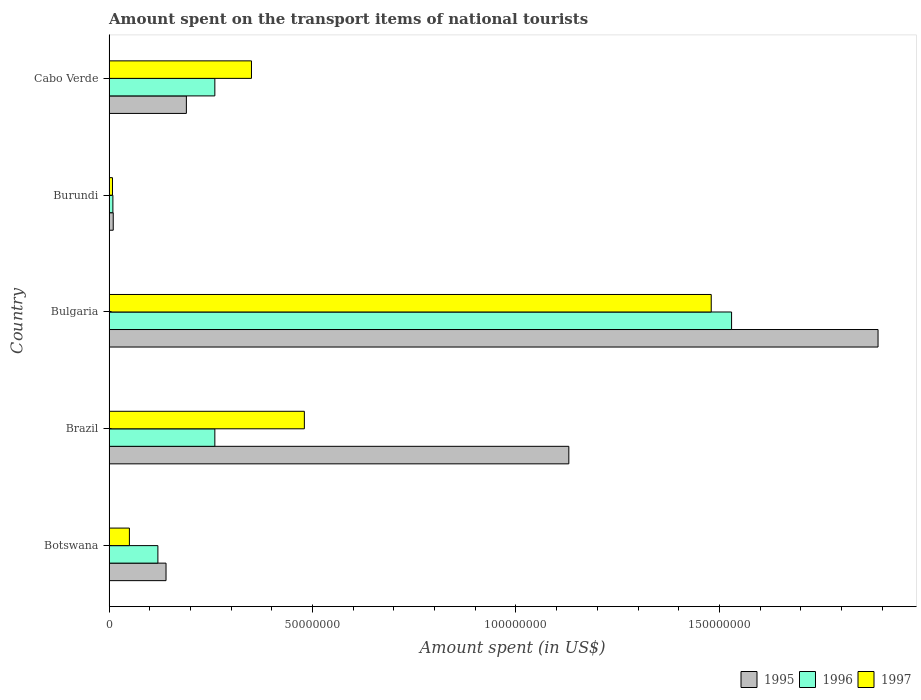How many bars are there on the 3rd tick from the top?
Provide a short and direct response. 3. What is the label of the 2nd group of bars from the top?
Provide a succinct answer. Burundi. What is the amount spent on the transport items of national tourists in 1997 in Botswana?
Provide a short and direct response. 5.00e+06. Across all countries, what is the maximum amount spent on the transport items of national tourists in 1995?
Offer a very short reply. 1.89e+08. Across all countries, what is the minimum amount spent on the transport items of national tourists in 1996?
Keep it short and to the point. 9.41e+05. In which country was the amount spent on the transport items of national tourists in 1996 minimum?
Keep it short and to the point. Burundi. What is the total amount spent on the transport items of national tourists in 1995 in the graph?
Keep it short and to the point. 3.36e+08. What is the difference between the amount spent on the transport items of national tourists in 1996 in Bulgaria and that in Burundi?
Give a very brief answer. 1.52e+08. What is the difference between the amount spent on the transport items of national tourists in 1996 in Brazil and the amount spent on the transport items of national tourists in 1997 in Cabo Verde?
Offer a terse response. -9.00e+06. What is the average amount spent on the transport items of national tourists in 1997 per country?
Make the answer very short. 4.74e+07. What is the difference between the amount spent on the transport items of national tourists in 1997 and amount spent on the transport items of national tourists in 1996 in Brazil?
Give a very brief answer. 2.20e+07. In how many countries, is the amount spent on the transport items of national tourists in 1996 greater than 110000000 US$?
Your answer should be compact. 1. What is the ratio of the amount spent on the transport items of national tourists in 1996 in Bulgaria to that in Burundi?
Ensure brevity in your answer.  162.53. What is the difference between the highest and the second highest amount spent on the transport items of national tourists in 1995?
Provide a short and direct response. 7.60e+07. What is the difference between the highest and the lowest amount spent on the transport items of national tourists in 1996?
Give a very brief answer. 1.52e+08. What does the 3rd bar from the bottom in Brazil represents?
Your answer should be very brief. 1997. What is the difference between two consecutive major ticks on the X-axis?
Your response must be concise. 5.00e+07. Does the graph contain any zero values?
Keep it short and to the point. No. Does the graph contain grids?
Keep it short and to the point. No. How are the legend labels stacked?
Provide a short and direct response. Horizontal. What is the title of the graph?
Offer a very short reply. Amount spent on the transport items of national tourists. Does "1980" appear as one of the legend labels in the graph?
Give a very brief answer. No. What is the label or title of the X-axis?
Ensure brevity in your answer.  Amount spent (in US$). What is the Amount spent (in US$) in 1995 in Botswana?
Your answer should be very brief. 1.40e+07. What is the Amount spent (in US$) of 1996 in Botswana?
Your answer should be very brief. 1.20e+07. What is the Amount spent (in US$) in 1997 in Botswana?
Make the answer very short. 5.00e+06. What is the Amount spent (in US$) in 1995 in Brazil?
Make the answer very short. 1.13e+08. What is the Amount spent (in US$) of 1996 in Brazil?
Give a very brief answer. 2.60e+07. What is the Amount spent (in US$) of 1997 in Brazil?
Make the answer very short. 4.80e+07. What is the Amount spent (in US$) in 1995 in Bulgaria?
Keep it short and to the point. 1.89e+08. What is the Amount spent (in US$) in 1996 in Bulgaria?
Your answer should be compact. 1.53e+08. What is the Amount spent (in US$) of 1997 in Bulgaria?
Offer a terse response. 1.48e+08. What is the Amount spent (in US$) of 1995 in Burundi?
Your response must be concise. 1.02e+06. What is the Amount spent (in US$) of 1996 in Burundi?
Your answer should be very brief. 9.41e+05. What is the Amount spent (in US$) in 1997 in Burundi?
Ensure brevity in your answer.  8.40e+05. What is the Amount spent (in US$) of 1995 in Cabo Verde?
Offer a terse response. 1.90e+07. What is the Amount spent (in US$) of 1996 in Cabo Verde?
Make the answer very short. 2.60e+07. What is the Amount spent (in US$) in 1997 in Cabo Verde?
Offer a very short reply. 3.50e+07. Across all countries, what is the maximum Amount spent (in US$) in 1995?
Your answer should be compact. 1.89e+08. Across all countries, what is the maximum Amount spent (in US$) of 1996?
Ensure brevity in your answer.  1.53e+08. Across all countries, what is the maximum Amount spent (in US$) of 1997?
Ensure brevity in your answer.  1.48e+08. Across all countries, what is the minimum Amount spent (in US$) in 1995?
Offer a terse response. 1.02e+06. Across all countries, what is the minimum Amount spent (in US$) in 1996?
Your response must be concise. 9.41e+05. Across all countries, what is the minimum Amount spent (in US$) of 1997?
Give a very brief answer. 8.40e+05. What is the total Amount spent (in US$) in 1995 in the graph?
Ensure brevity in your answer.  3.36e+08. What is the total Amount spent (in US$) in 1996 in the graph?
Make the answer very short. 2.18e+08. What is the total Amount spent (in US$) in 1997 in the graph?
Your response must be concise. 2.37e+08. What is the difference between the Amount spent (in US$) in 1995 in Botswana and that in Brazil?
Provide a succinct answer. -9.90e+07. What is the difference between the Amount spent (in US$) in 1996 in Botswana and that in Brazil?
Your answer should be compact. -1.40e+07. What is the difference between the Amount spent (in US$) in 1997 in Botswana and that in Brazil?
Offer a very short reply. -4.30e+07. What is the difference between the Amount spent (in US$) in 1995 in Botswana and that in Bulgaria?
Provide a short and direct response. -1.75e+08. What is the difference between the Amount spent (in US$) of 1996 in Botswana and that in Bulgaria?
Offer a terse response. -1.41e+08. What is the difference between the Amount spent (in US$) in 1997 in Botswana and that in Bulgaria?
Ensure brevity in your answer.  -1.43e+08. What is the difference between the Amount spent (in US$) of 1995 in Botswana and that in Burundi?
Provide a succinct answer. 1.30e+07. What is the difference between the Amount spent (in US$) in 1996 in Botswana and that in Burundi?
Give a very brief answer. 1.11e+07. What is the difference between the Amount spent (in US$) of 1997 in Botswana and that in Burundi?
Offer a terse response. 4.16e+06. What is the difference between the Amount spent (in US$) of 1995 in Botswana and that in Cabo Verde?
Offer a very short reply. -5.00e+06. What is the difference between the Amount spent (in US$) of 1996 in Botswana and that in Cabo Verde?
Your response must be concise. -1.40e+07. What is the difference between the Amount spent (in US$) of 1997 in Botswana and that in Cabo Verde?
Ensure brevity in your answer.  -3.00e+07. What is the difference between the Amount spent (in US$) in 1995 in Brazil and that in Bulgaria?
Ensure brevity in your answer.  -7.60e+07. What is the difference between the Amount spent (in US$) in 1996 in Brazil and that in Bulgaria?
Offer a very short reply. -1.27e+08. What is the difference between the Amount spent (in US$) of 1997 in Brazil and that in Bulgaria?
Your response must be concise. -1.00e+08. What is the difference between the Amount spent (in US$) in 1995 in Brazil and that in Burundi?
Provide a succinct answer. 1.12e+08. What is the difference between the Amount spent (in US$) of 1996 in Brazil and that in Burundi?
Ensure brevity in your answer.  2.51e+07. What is the difference between the Amount spent (in US$) of 1997 in Brazil and that in Burundi?
Give a very brief answer. 4.72e+07. What is the difference between the Amount spent (in US$) in 1995 in Brazil and that in Cabo Verde?
Your answer should be compact. 9.40e+07. What is the difference between the Amount spent (in US$) in 1996 in Brazil and that in Cabo Verde?
Keep it short and to the point. 0. What is the difference between the Amount spent (in US$) in 1997 in Brazil and that in Cabo Verde?
Your response must be concise. 1.30e+07. What is the difference between the Amount spent (in US$) in 1995 in Bulgaria and that in Burundi?
Make the answer very short. 1.88e+08. What is the difference between the Amount spent (in US$) of 1996 in Bulgaria and that in Burundi?
Ensure brevity in your answer.  1.52e+08. What is the difference between the Amount spent (in US$) in 1997 in Bulgaria and that in Burundi?
Give a very brief answer. 1.47e+08. What is the difference between the Amount spent (in US$) in 1995 in Bulgaria and that in Cabo Verde?
Your answer should be compact. 1.70e+08. What is the difference between the Amount spent (in US$) in 1996 in Bulgaria and that in Cabo Verde?
Provide a short and direct response. 1.27e+08. What is the difference between the Amount spent (in US$) in 1997 in Bulgaria and that in Cabo Verde?
Keep it short and to the point. 1.13e+08. What is the difference between the Amount spent (in US$) of 1995 in Burundi and that in Cabo Verde?
Offer a very short reply. -1.80e+07. What is the difference between the Amount spent (in US$) in 1996 in Burundi and that in Cabo Verde?
Your response must be concise. -2.51e+07. What is the difference between the Amount spent (in US$) of 1997 in Burundi and that in Cabo Verde?
Your answer should be compact. -3.42e+07. What is the difference between the Amount spent (in US$) in 1995 in Botswana and the Amount spent (in US$) in 1996 in Brazil?
Give a very brief answer. -1.20e+07. What is the difference between the Amount spent (in US$) of 1995 in Botswana and the Amount spent (in US$) of 1997 in Brazil?
Ensure brevity in your answer.  -3.40e+07. What is the difference between the Amount spent (in US$) in 1996 in Botswana and the Amount spent (in US$) in 1997 in Brazil?
Keep it short and to the point. -3.60e+07. What is the difference between the Amount spent (in US$) in 1995 in Botswana and the Amount spent (in US$) in 1996 in Bulgaria?
Your answer should be very brief. -1.39e+08. What is the difference between the Amount spent (in US$) of 1995 in Botswana and the Amount spent (in US$) of 1997 in Bulgaria?
Offer a terse response. -1.34e+08. What is the difference between the Amount spent (in US$) in 1996 in Botswana and the Amount spent (in US$) in 1997 in Bulgaria?
Your answer should be very brief. -1.36e+08. What is the difference between the Amount spent (in US$) in 1995 in Botswana and the Amount spent (in US$) in 1996 in Burundi?
Ensure brevity in your answer.  1.31e+07. What is the difference between the Amount spent (in US$) of 1995 in Botswana and the Amount spent (in US$) of 1997 in Burundi?
Make the answer very short. 1.32e+07. What is the difference between the Amount spent (in US$) in 1996 in Botswana and the Amount spent (in US$) in 1997 in Burundi?
Provide a succinct answer. 1.12e+07. What is the difference between the Amount spent (in US$) of 1995 in Botswana and the Amount spent (in US$) of 1996 in Cabo Verde?
Make the answer very short. -1.20e+07. What is the difference between the Amount spent (in US$) in 1995 in Botswana and the Amount spent (in US$) in 1997 in Cabo Verde?
Provide a short and direct response. -2.10e+07. What is the difference between the Amount spent (in US$) in 1996 in Botswana and the Amount spent (in US$) in 1997 in Cabo Verde?
Your answer should be very brief. -2.30e+07. What is the difference between the Amount spent (in US$) in 1995 in Brazil and the Amount spent (in US$) in 1996 in Bulgaria?
Your response must be concise. -4.00e+07. What is the difference between the Amount spent (in US$) in 1995 in Brazil and the Amount spent (in US$) in 1997 in Bulgaria?
Keep it short and to the point. -3.50e+07. What is the difference between the Amount spent (in US$) of 1996 in Brazil and the Amount spent (in US$) of 1997 in Bulgaria?
Make the answer very short. -1.22e+08. What is the difference between the Amount spent (in US$) in 1995 in Brazil and the Amount spent (in US$) in 1996 in Burundi?
Your answer should be very brief. 1.12e+08. What is the difference between the Amount spent (in US$) of 1995 in Brazil and the Amount spent (in US$) of 1997 in Burundi?
Your answer should be very brief. 1.12e+08. What is the difference between the Amount spent (in US$) of 1996 in Brazil and the Amount spent (in US$) of 1997 in Burundi?
Your response must be concise. 2.52e+07. What is the difference between the Amount spent (in US$) in 1995 in Brazil and the Amount spent (in US$) in 1996 in Cabo Verde?
Your response must be concise. 8.70e+07. What is the difference between the Amount spent (in US$) of 1995 in Brazil and the Amount spent (in US$) of 1997 in Cabo Verde?
Provide a short and direct response. 7.80e+07. What is the difference between the Amount spent (in US$) in 1996 in Brazil and the Amount spent (in US$) in 1997 in Cabo Verde?
Offer a very short reply. -9.00e+06. What is the difference between the Amount spent (in US$) of 1995 in Bulgaria and the Amount spent (in US$) of 1996 in Burundi?
Provide a succinct answer. 1.88e+08. What is the difference between the Amount spent (in US$) of 1995 in Bulgaria and the Amount spent (in US$) of 1997 in Burundi?
Provide a succinct answer. 1.88e+08. What is the difference between the Amount spent (in US$) of 1996 in Bulgaria and the Amount spent (in US$) of 1997 in Burundi?
Provide a succinct answer. 1.52e+08. What is the difference between the Amount spent (in US$) in 1995 in Bulgaria and the Amount spent (in US$) in 1996 in Cabo Verde?
Provide a short and direct response. 1.63e+08. What is the difference between the Amount spent (in US$) in 1995 in Bulgaria and the Amount spent (in US$) in 1997 in Cabo Verde?
Your answer should be compact. 1.54e+08. What is the difference between the Amount spent (in US$) in 1996 in Bulgaria and the Amount spent (in US$) in 1997 in Cabo Verde?
Offer a very short reply. 1.18e+08. What is the difference between the Amount spent (in US$) in 1995 in Burundi and the Amount spent (in US$) in 1996 in Cabo Verde?
Provide a short and direct response. -2.50e+07. What is the difference between the Amount spent (in US$) of 1995 in Burundi and the Amount spent (in US$) of 1997 in Cabo Verde?
Ensure brevity in your answer.  -3.40e+07. What is the difference between the Amount spent (in US$) of 1996 in Burundi and the Amount spent (in US$) of 1997 in Cabo Verde?
Offer a terse response. -3.41e+07. What is the average Amount spent (in US$) of 1995 per country?
Give a very brief answer. 6.72e+07. What is the average Amount spent (in US$) of 1996 per country?
Keep it short and to the point. 4.36e+07. What is the average Amount spent (in US$) in 1997 per country?
Make the answer very short. 4.74e+07. What is the difference between the Amount spent (in US$) of 1995 and Amount spent (in US$) of 1997 in Botswana?
Provide a short and direct response. 9.00e+06. What is the difference between the Amount spent (in US$) in 1995 and Amount spent (in US$) in 1996 in Brazil?
Ensure brevity in your answer.  8.70e+07. What is the difference between the Amount spent (in US$) in 1995 and Amount spent (in US$) in 1997 in Brazil?
Provide a succinct answer. 6.50e+07. What is the difference between the Amount spent (in US$) of 1996 and Amount spent (in US$) of 1997 in Brazil?
Make the answer very short. -2.20e+07. What is the difference between the Amount spent (in US$) of 1995 and Amount spent (in US$) of 1996 in Bulgaria?
Offer a very short reply. 3.60e+07. What is the difference between the Amount spent (in US$) in 1995 and Amount spent (in US$) in 1997 in Bulgaria?
Give a very brief answer. 4.10e+07. What is the difference between the Amount spent (in US$) in 1995 and Amount spent (in US$) in 1996 in Burundi?
Your response must be concise. 8.36e+04. What is the difference between the Amount spent (in US$) in 1995 and Amount spent (in US$) in 1997 in Burundi?
Your answer should be very brief. 1.85e+05. What is the difference between the Amount spent (in US$) of 1996 and Amount spent (in US$) of 1997 in Burundi?
Provide a short and direct response. 1.01e+05. What is the difference between the Amount spent (in US$) in 1995 and Amount spent (in US$) in 1996 in Cabo Verde?
Give a very brief answer. -7.00e+06. What is the difference between the Amount spent (in US$) of 1995 and Amount spent (in US$) of 1997 in Cabo Verde?
Offer a very short reply. -1.60e+07. What is the difference between the Amount spent (in US$) in 1996 and Amount spent (in US$) in 1997 in Cabo Verde?
Offer a terse response. -9.00e+06. What is the ratio of the Amount spent (in US$) of 1995 in Botswana to that in Brazil?
Your answer should be very brief. 0.12. What is the ratio of the Amount spent (in US$) of 1996 in Botswana to that in Brazil?
Keep it short and to the point. 0.46. What is the ratio of the Amount spent (in US$) of 1997 in Botswana to that in Brazil?
Ensure brevity in your answer.  0.1. What is the ratio of the Amount spent (in US$) in 1995 in Botswana to that in Bulgaria?
Your answer should be very brief. 0.07. What is the ratio of the Amount spent (in US$) in 1996 in Botswana to that in Bulgaria?
Offer a terse response. 0.08. What is the ratio of the Amount spent (in US$) of 1997 in Botswana to that in Bulgaria?
Ensure brevity in your answer.  0.03. What is the ratio of the Amount spent (in US$) of 1995 in Botswana to that in Burundi?
Give a very brief answer. 13.66. What is the ratio of the Amount spent (in US$) in 1996 in Botswana to that in Burundi?
Your answer should be compact. 12.75. What is the ratio of the Amount spent (in US$) of 1997 in Botswana to that in Burundi?
Keep it short and to the point. 5.95. What is the ratio of the Amount spent (in US$) of 1995 in Botswana to that in Cabo Verde?
Provide a succinct answer. 0.74. What is the ratio of the Amount spent (in US$) in 1996 in Botswana to that in Cabo Verde?
Your answer should be very brief. 0.46. What is the ratio of the Amount spent (in US$) of 1997 in Botswana to that in Cabo Verde?
Give a very brief answer. 0.14. What is the ratio of the Amount spent (in US$) of 1995 in Brazil to that in Bulgaria?
Your answer should be compact. 0.6. What is the ratio of the Amount spent (in US$) of 1996 in Brazil to that in Bulgaria?
Make the answer very short. 0.17. What is the ratio of the Amount spent (in US$) of 1997 in Brazil to that in Bulgaria?
Keep it short and to the point. 0.32. What is the ratio of the Amount spent (in US$) of 1995 in Brazil to that in Burundi?
Give a very brief answer. 110.24. What is the ratio of the Amount spent (in US$) of 1996 in Brazil to that in Burundi?
Your response must be concise. 27.62. What is the ratio of the Amount spent (in US$) in 1997 in Brazil to that in Burundi?
Make the answer very short. 57.14. What is the ratio of the Amount spent (in US$) of 1995 in Brazil to that in Cabo Verde?
Offer a very short reply. 5.95. What is the ratio of the Amount spent (in US$) in 1997 in Brazil to that in Cabo Verde?
Your response must be concise. 1.37. What is the ratio of the Amount spent (in US$) in 1995 in Bulgaria to that in Burundi?
Make the answer very short. 184.39. What is the ratio of the Amount spent (in US$) in 1996 in Bulgaria to that in Burundi?
Provide a short and direct response. 162.53. What is the ratio of the Amount spent (in US$) of 1997 in Bulgaria to that in Burundi?
Provide a short and direct response. 176.18. What is the ratio of the Amount spent (in US$) in 1995 in Bulgaria to that in Cabo Verde?
Provide a short and direct response. 9.95. What is the ratio of the Amount spent (in US$) in 1996 in Bulgaria to that in Cabo Verde?
Your response must be concise. 5.88. What is the ratio of the Amount spent (in US$) in 1997 in Bulgaria to that in Cabo Verde?
Offer a terse response. 4.23. What is the ratio of the Amount spent (in US$) of 1995 in Burundi to that in Cabo Verde?
Offer a very short reply. 0.05. What is the ratio of the Amount spent (in US$) in 1996 in Burundi to that in Cabo Verde?
Keep it short and to the point. 0.04. What is the ratio of the Amount spent (in US$) of 1997 in Burundi to that in Cabo Verde?
Keep it short and to the point. 0.02. What is the difference between the highest and the second highest Amount spent (in US$) in 1995?
Offer a terse response. 7.60e+07. What is the difference between the highest and the second highest Amount spent (in US$) of 1996?
Ensure brevity in your answer.  1.27e+08. What is the difference between the highest and the lowest Amount spent (in US$) in 1995?
Offer a very short reply. 1.88e+08. What is the difference between the highest and the lowest Amount spent (in US$) of 1996?
Offer a terse response. 1.52e+08. What is the difference between the highest and the lowest Amount spent (in US$) of 1997?
Provide a succinct answer. 1.47e+08. 